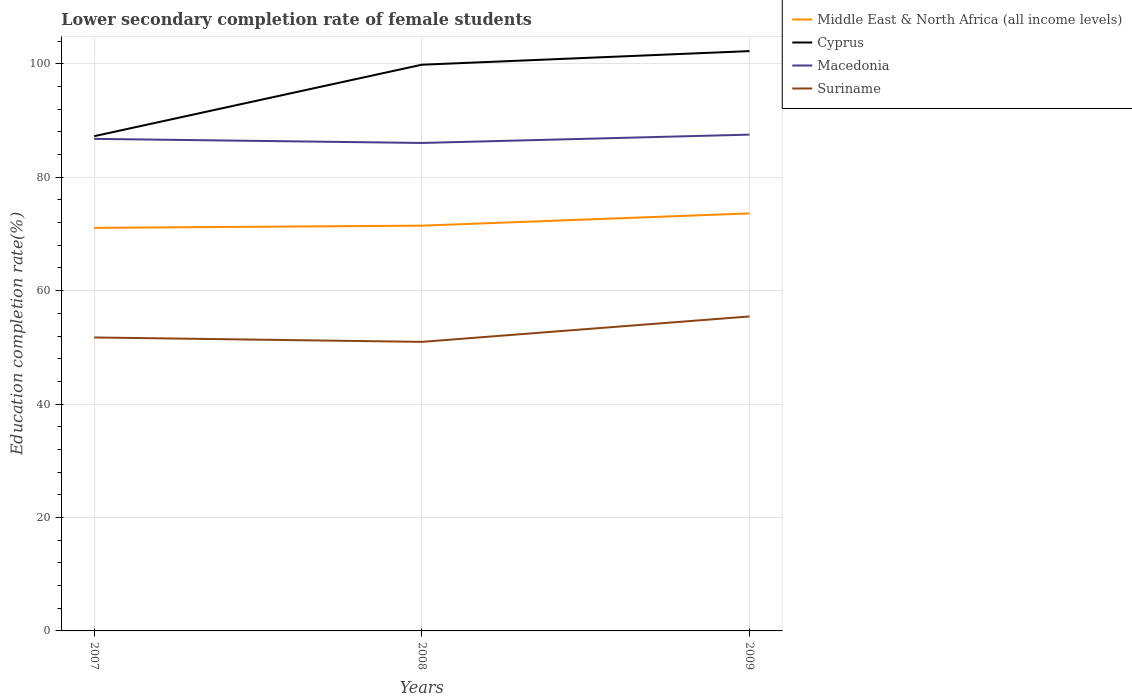Is the number of lines equal to the number of legend labels?
Provide a succinct answer. Yes. Across all years, what is the maximum lower secondary completion rate of female students in Suriname?
Your answer should be very brief. 50.97. What is the total lower secondary completion rate of female students in Middle East & North Africa (all income levels) in the graph?
Your answer should be compact. -0.39. What is the difference between the highest and the second highest lower secondary completion rate of female students in Suriname?
Make the answer very short. 4.48. What is the difference between the highest and the lowest lower secondary completion rate of female students in Suriname?
Provide a succinct answer. 1. Is the lower secondary completion rate of female students in Suriname strictly greater than the lower secondary completion rate of female students in Cyprus over the years?
Ensure brevity in your answer.  Yes. Are the values on the major ticks of Y-axis written in scientific E-notation?
Provide a short and direct response. No. Where does the legend appear in the graph?
Ensure brevity in your answer.  Top right. How many legend labels are there?
Your answer should be very brief. 4. What is the title of the graph?
Your answer should be compact. Lower secondary completion rate of female students. Does "Latvia" appear as one of the legend labels in the graph?
Offer a terse response. No. What is the label or title of the Y-axis?
Your response must be concise. Education completion rate(%). What is the Education completion rate(%) of Middle East & North Africa (all income levels) in 2007?
Provide a succinct answer. 71.07. What is the Education completion rate(%) in Cyprus in 2007?
Your answer should be very brief. 87.23. What is the Education completion rate(%) in Macedonia in 2007?
Keep it short and to the point. 86.76. What is the Education completion rate(%) in Suriname in 2007?
Offer a very short reply. 51.74. What is the Education completion rate(%) in Middle East & North Africa (all income levels) in 2008?
Provide a short and direct response. 71.46. What is the Education completion rate(%) of Cyprus in 2008?
Ensure brevity in your answer.  99.83. What is the Education completion rate(%) of Macedonia in 2008?
Your response must be concise. 86.04. What is the Education completion rate(%) of Suriname in 2008?
Keep it short and to the point. 50.97. What is the Education completion rate(%) in Middle East & North Africa (all income levels) in 2009?
Ensure brevity in your answer.  73.62. What is the Education completion rate(%) of Cyprus in 2009?
Provide a short and direct response. 102.23. What is the Education completion rate(%) in Macedonia in 2009?
Give a very brief answer. 87.51. What is the Education completion rate(%) of Suriname in 2009?
Provide a succinct answer. 55.45. Across all years, what is the maximum Education completion rate(%) of Middle East & North Africa (all income levels)?
Keep it short and to the point. 73.62. Across all years, what is the maximum Education completion rate(%) in Cyprus?
Provide a succinct answer. 102.23. Across all years, what is the maximum Education completion rate(%) of Macedonia?
Keep it short and to the point. 87.51. Across all years, what is the maximum Education completion rate(%) in Suriname?
Make the answer very short. 55.45. Across all years, what is the minimum Education completion rate(%) in Middle East & North Africa (all income levels)?
Your response must be concise. 71.07. Across all years, what is the minimum Education completion rate(%) of Cyprus?
Your answer should be very brief. 87.23. Across all years, what is the minimum Education completion rate(%) in Macedonia?
Ensure brevity in your answer.  86.04. Across all years, what is the minimum Education completion rate(%) in Suriname?
Your answer should be very brief. 50.97. What is the total Education completion rate(%) of Middle East & North Africa (all income levels) in the graph?
Your response must be concise. 216.14. What is the total Education completion rate(%) in Cyprus in the graph?
Offer a very short reply. 289.3. What is the total Education completion rate(%) in Macedonia in the graph?
Offer a very short reply. 260.31. What is the total Education completion rate(%) of Suriname in the graph?
Make the answer very short. 158.16. What is the difference between the Education completion rate(%) in Middle East & North Africa (all income levels) in 2007 and that in 2008?
Your answer should be compact. -0.39. What is the difference between the Education completion rate(%) of Cyprus in 2007 and that in 2008?
Ensure brevity in your answer.  -12.6. What is the difference between the Education completion rate(%) of Macedonia in 2007 and that in 2008?
Give a very brief answer. 0.72. What is the difference between the Education completion rate(%) of Suriname in 2007 and that in 2008?
Offer a terse response. 0.78. What is the difference between the Education completion rate(%) in Middle East & North Africa (all income levels) in 2007 and that in 2009?
Keep it short and to the point. -2.55. What is the difference between the Education completion rate(%) in Cyprus in 2007 and that in 2009?
Offer a terse response. -15. What is the difference between the Education completion rate(%) in Macedonia in 2007 and that in 2009?
Provide a short and direct response. -0.75. What is the difference between the Education completion rate(%) in Suriname in 2007 and that in 2009?
Your answer should be very brief. -3.71. What is the difference between the Education completion rate(%) of Middle East & North Africa (all income levels) in 2008 and that in 2009?
Provide a succinct answer. -2.16. What is the difference between the Education completion rate(%) in Cyprus in 2008 and that in 2009?
Offer a very short reply. -2.4. What is the difference between the Education completion rate(%) in Macedonia in 2008 and that in 2009?
Provide a succinct answer. -1.47. What is the difference between the Education completion rate(%) of Suriname in 2008 and that in 2009?
Keep it short and to the point. -4.48. What is the difference between the Education completion rate(%) of Middle East & North Africa (all income levels) in 2007 and the Education completion rate(%) of Cyprus in 2008?
Make the answer very short. -28.77. What is the difference between the Education completion rate(%) of Middle East & North Africa (all income levels) in 2007 and the Education completion rate(%) of Macedonia in 2008?
Offer a terse response. -14.97. What is the difference between the Education completion rate(%) of Middle East & North Africa (all income levels) in 2007 and the Education completion rate(%) of Suriname in 2008?
Your answer should be compact. 20.1. What is the difference between the Education completion rate(%) in Cyprus in 2007 and the Education completion rate(%) in Macedonia in 2008?
Ensure brevity in your answer.  1.19. What is the difference between the Education completion rate(%) in Cyprus in 2007 and the Education completion rate(%) in Suriname in 2008?
Keep it short and to the point. 36.26. What is the difference between the Education completion rate(%) of Macedonia in 2007 and the Education completion rate(%) of Suriname in 2008?
Your answer should be very brief. 35.79. What is the difference between the Education completion rate(%) in Middle East & North Africa (all income levels) in 2007 and the Education completion rate(%) in Cyprus in 2009?
Your answer should be compact. -31.17. What is the difference between the Education completion rate(%) in Middle East & North Africa (all income levels) in 2007 and the Education completion rate(%) in Macedonia in 2009?
Your response must be concise. -16.44. What is the difference between the Education completion rate(%) in Middle East & North Africa (all income levels) in 2007 and the Education completion rate(%) in Suriname in 2009?
Make the answer very short. 15.62. What is the difference between the Education completion rate(%) in Cyprus in 2007 and the Education completion rate(%) in Macedonia in 2009?
Your response must be concise. -0.28. What is the difference between the Education completion rate(%) in Cyprus in 2007 and the Education completion rate(%) in Suriname in 2009?
Your answer should be very brief. 31.78. What is the difference between the Education completion rate(%) of Macedonia in 2007 and the Education completion rate(%) of Suriname in 2009?
Make the answer very short. 31.31. What is the difference between the Education completion rate(%) in Middle East & North Africa (all income levels) in 2008 and the Education completion rate(%) in Cyprus in 2009?
Your response must be concise. -30.78. What is the difference between the Education completion rate(%) of Middle East & North Africa (all income levels) in 2008 and the Education completion rate(%) of Macedonia in 2009?
Provide a succinct answer. -16.05. What is the difference between the Education completion rate(%) of Middle East & North Africa (all income levels) in 2008 and the Education completion rate(%) of Suriname in 2009?
Offer a terse response. 16.01. What is the difference between the Education completion rate(%) in Cyprus in 2008 and the Education completion rate(%) in Macedonia in 2009?
Offer a very short reply. 12.33. What is the difference between the Education completion rate(%) of Cyprus in 2008 and the Education completion rate(%) of Suriname in 2009?
Offer a very short reply. 44.38. What is the difference between the Education completion rate(%) of Macedonia in 2008 and the Education completion rate(%) of Suriname in 2009?
Keep it short and to the point. 30.59. What is the average Education completion rate(%) of Middle East & North Africa (all income levels) per year?
Keep it short and to the point. 72.05. What is the average Education completion rate(%) of Cyprus per year?
Offer a terse response. 96.43. What is the average Education completion rate(%) in Macedonia per year?
Your response must be concise. 86.77. What is the average Education completion rate(%) of Suriname per year?
Offer a terse response. 52.72. In the year 2007, what is the difference between the Education completion rate(%) of Middle East & North Africa (all income levels) and Education completion rate(%) of Cyprus?
Offer a very short reply. -16.16. In the year 2007, what is the difference between the Education completion rate(%) of Middle East & North Africa (all income levels) and Education completion rate(%) of Macedonia?
Offer a very short reply. -15.69. In the year 2007, what is the difference between the Education completion rate(%) in Middle East & North Africa (all income levels) and Education completion rate(%) in Suriname?
Give a very brief answer. 19.32. In the year 2007, what is the difference between the Education completion rate(%) in Cyprus and Education completion rate(%) in Macedonia?
Make the answer very short. 0.47. In the year 2007, what is the difference between the Education completion rate(%) of Cyprus and Education completion rate(%) of Suriname?
Offer a terse response. 35.49. In the year 2007, what is the difference between the Education completion rate(%) of Macedonia and Education completion rate(%) of Suriname?
Ensure brevity in your answer.  35.02. In the year 2008, what is the difference between the Education completion rate(%) in Middle East & North Africa (all income levels) and Education completion rate(%) in Cyprus?
Offer a very short reply. -28.38. In the year 2008, what is the difference between the Education completion rate(%) of Middle East & North Africa (all income levels) and Education completion rate(%) of Macedonia?
Provide a succinct answer. -14.58. In the year 2008, what is the difference between the Education completion rate(%) of Middle East & North Africa (all income levels) and Education completion rate(%) of Suriname?
Offer a terse response. 20.49. In the year 2008, what is the difference between the Education completion rate(%) of Cyprus and Education completion rate(%) of Macedonia?
Your answer should be very brief. 13.79. In the year 2008, what is the difference between the Education completion rate(%) of Cyprus and Education completion rate(%) of Suriname?
Offer a very short reply. 48.87. In the year 2008, what is the difference between the Education completion rate(%) in Macedonia and Education completion rate(%) in Suriname?
Give a very brief answer. 35.07. In the year 2009, what is the difference between the Education completion rate(%) in Middle East & North Africa (all income levels) and Education completion rate(%) in Cyprus?
Offer a very short reply. -28.62. In the year 2009, what is the difference between the Education completion rate(%) of Middle East & North Africa (all income levels) and Education completion rate(%) of Macedonia?
Ensure brevity in your answer.  -13.89. In the year 2009, what is the difference between the Education completion rate(%) of Middle East & North Africa (all income levels) and Education completion rate(%) of Suriname?
Your answer should be very brief. 18.17. In the year 2009, what is the difference between the Education completion rate(%) in Cyprus and Education completion rate(%) in Macedonia?
Make the answer very short. 14.73. In the year 2009, what is the difference between the Education completion rate(%) of Cyprus and Education completion rate(%) of Suriname?
Provide a succinct answer. 46.78. In the year 2009, what is the difference between the Education completion rate(%) in Macedonia and Education completion rate(%) in Suriname?
Your response must be concise. 32.06. What is the ratio of the Education completion rate(%) in Cyprus in 2007 to that in 2008?
Offer a terse response. 0.87. What is the ratio of the Education completion rate(%) of Macedonia in 2007 to that in 2008?
Keep it short and to the point. 1.01. What is the ratio of the Education completion rate(%) in Suriname in 2007 to that in 2008?
Provide a succinct answer. 1.02. What is the ratio of the Education completion rate(%) in Middle East & North Africa (all income levels) in 2007 to that in 2009?
Your answer should be compact. 0.97. What is the ratio of the Education completion rate(%) in Cyprus in 2007 to that in 2009?
Your answer should be very brief. 0.85. What is the ratio of the Education completion rate(%) of Macedonia in 2007 to that in 2009?
Provide a succinct answer. 0.99. What is the ratio of the Education completion rate(%) in Suriname in 2007 to that in 2009?
Keep it short and to the point. 0.93. What is the ratio of the Education completion rate(%) of Middle East & North Africa (all income levels) in 2008 to that in 2009?
Provide a succinct answer. 0.97. What is the ratio of the Education completion rate(%) of Cyprus in 2008 to that in 2009?
Give a very brief answer. 0.98. What is the ratio of the Education completion rate(%) in Macedonia in 2008 to that in 2009?
Your answer should be compact. 0.98. What is the ratio of the Education completion rate(%) in Suriname in 2008 to that in 2009?
Ensure brevity in your answer.  0.92. What is the difference between the highest and the second highest Education completion rate(%) in Middle East & North Africa (all income levels)?
Your answer should be compact. 2.16. What is the difference between the highest and the second highest Education completion rate(%) in Cyprus?
Ensure brevity in your answer.  2.4. What is the difference between the highest and the second highest Education completion rate(%) in Macedonia?
Provide a succinct answer. 0.75. What is the difference between the highest and the second highest Education completion rate(%) of Suriname?
Provide a succinct answer. 3.71. What is the difference between the highest and the lowest Education completion rate(%) of Middle East & North Africa (all income levels)?
Offer a terse response. 2.55. What is the difference between the highest and the lowest Education completion rate(%) of Cyprus?
Your response must be concise. 15. What is the difference between the highest and the lowest Education completion rate(%) in Macedonia?
Your answer should be very brief. 1.47. What is the difference between the highest and the lowest Education completion rate(%) of Suriname?
Give a very brief answer. 4.48. 